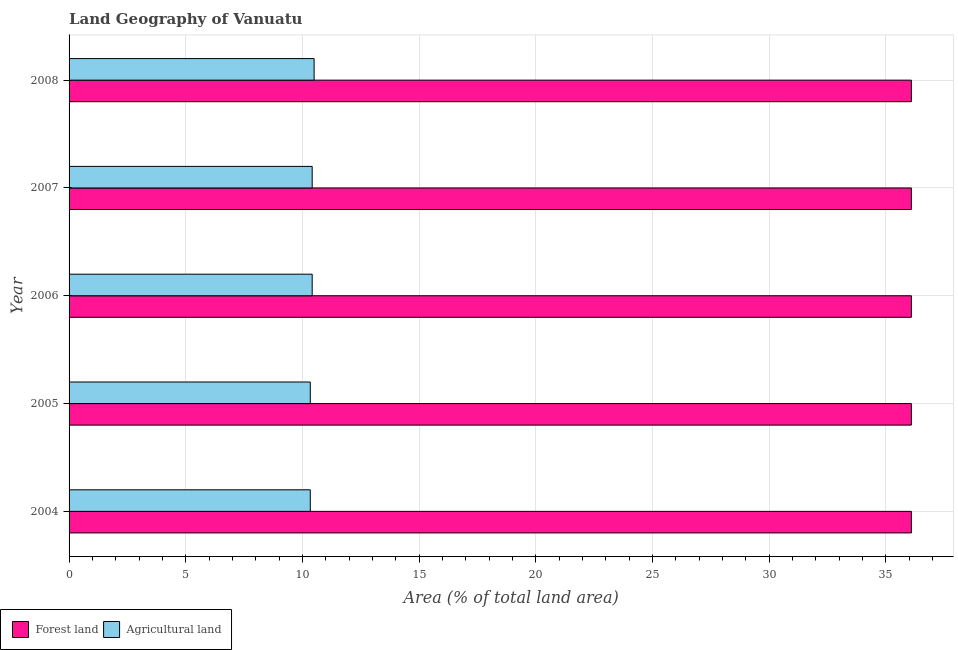How many different coloured bars are there?
Make the answer very short. 2. Are the number of bars per tick equal to the number of legend labels?
Your response must be concise. Yes. Are the number of bars on each tick of the Y-axis equal?
Give a very brief answer. Yes. How many bars are there on the 4th tick from the top?
Keep it short and to the point. 2. How many bars are there on the 2nd tick from the bottom?
Offer a terse response. 2. What is the label of the 5th group of bars from the top?
Ensure brevity in your answer.  2004. What is the percentage of land area under forests in 2005?
Keep it short and to the point. 36.1. Across all years, what is the maximum percentage of land area under agriculture?
Your answer should be very brief. 10.5. Across all years, what is the minimum percentage of land area under agriculture?
Your response must be concise. 10.34. In which year was the percentage of land area under agriculture maximum?
Offer a very short reply. 2008. In which year was the percentage of land area under forests minimum?
Your answer should be compact. 2004. What is the total percentage of land area under agriculture in the graph?
Offer a terse response. 52.01. What is the difference between the percentage of land area under agriculture in 2004 and that in 2006?
Provide a short and direct response. -0.08. What is the difference between the percentage of land area under forests in 2005 and the percentage of land area under agriculture in 2008?
Your answer should be very brief. 25.59. What is the average percentage of land area under forests per year?
Your response must be concise. 36.09. In the year 2004, what is the difference between the percentage of land area under forests and percentage of land area under agriculture?
Your answer should be very brief. 25.76. Is the percentage of land area under forests in 2004 less than that in 2005?
Keep it short and to the point. No. What is the difference between the highest and the lowest percentage of land area under agriculture?
Offer a terse response. 0.16. In how many years, is the percentage of land area under agriculture greater than the average percentage of land area under agriculture taken over all years?
Your response must be concise. 3. What does the 1st bar from the top in 2005 represents?
Your response must be concise. Agricultural land. What does the 2nd bar from the bottom in 2007 represents?
Your answer should be compact. Agricultural land. How many bars are there?
Ensure brevity in your answer.  10. Are all the bars in the graph horizontal?
Your answer should be compact. Yes. Are the values on the major ticks of X-axis written in scientific E-notation?
Offer a very short reply. No. Where does the legend appear in the graph?
Offer a very short reply. Bottom left. What is the title of the graph?
Make the answer very short. Land Geography of Vanuatu. Does "Private creditors" appear as one of the legend labels in the graph?
Provide a short and direct response. No. What is the label or title of the X-axis?
Make the answer very short. Area (% of total land area). What is the label or title of the Y-axis?
Your answer should be compact. Year. What is the Area (% of total land area) of Forest land in 2004?
Your answer should be very brief. 36.1. What is the Area (% of total land area) of Agricultural land in 2004?
Your answer should be very brief. 10.34. What is the Area (% of total land area) in Forest land in 2005?
Offer a terse response. 36.1. What is the Area (% of total land area) of Agricultural land in 2005?
Offer a very short reply. 10.34. What is the Area (% of total land area) of Forest land in 2006?
Keep it short and to the point. 36.1. What is the Area (% of total land area) in Agricultural land in 2006?
Make the answer very short. 10.42. What is the Area (% of total land area) in Forest land in 2007?
Ensure brevity in your answer.  36.1. What is the Area (% of total land area) of Agricultural land in 2007?
Keep it short and to the point. 10.42. What is the Area (% of total land area) in Forest land in 2008?
Your answer should be very brief. 36.1. What is the Area (% of total land area) of Agricultural land in 2008?
Provide a short and direct response. 10.5. Across all years, what is the maximum Area (% of total land area) of Forest land?
Provide a short and direct response. 36.1. Across all years, what is the maximum Area (% of total land area) of Agricultural land?
Your response must be concise. 10.5. Across all years, what is the minimum Area (% of total land area) in Forest land?
Give a very brief answer. 36.1. Across all years, what is the minimum Area (% of total land area) in Agricultural land?
Your answer should be compact. 10.34. What is the total Area (% of total land area) of Forest land in the graph?
Your answer should be compact. 180.48. What is the total Area (% of total land area) of Agricultural land in the graph?
Your answer should be very brief. 52.01. What is the difference between the Area (% of total land area) in Forest land in 2004 and that in 2005?
Offer a very short reply. 0. What is the difference between the Area (% of total land area) in Forest land in 2004 and that in 2006?
Keep it short and to the point. 0. What is the difference between the Area (% of total land area) in Agricultural land in 2004 and that in 2006?
Provide a succinct answer. -0.08. What is the difference between the Area (% of total land area) in Forest land in 2004 and that in 2007?
Offer a very short reply. 0. What is the difference between the Area (% of total land area) of Agricultural land in 2004 and that in 2007?
Offer a terse response. -0.08. What is the difference between the Area (% of total land area) in Agricultural land in 2004 and that in 2008?
Provide a succinct answer. -0.16. What is the difference between the Area (% of total land area) in Forest land in 2005 and that in 2006?
Your answer should be compact. 0. What is the difference between the Area (% of total land area) in Agricultural land in 2005 and that in 2006?
Your answer should be very brief. -0.08. What is the difference between the Area (% of total land area) of Forest land in 2005 and that in 2007?
Keep it short and to the point. 0. What is the difference between the Area (% of total land area) in Agricultural land in 2005 and that in 2007?
Make the answer very short. -0.08. What is the difference between the Area (% of total land area) in Forest land in 2005 and that in 2008?
Make the answer very short. 0. What is the difference between the Area (% of total land area) of Agricultural land in 2005 and that in 2008?
Give a very brief answer. -0.16. What is the difference between the Area (% of total land area) in Agricultural land in 2006 and that in 2007?
Offer a very short reply. 0. What is the difference between the Area (% of total land area) in Forest land in 2006 and that in 2008?
Provide a short and direct response. 0. What is the difference between the Area (% of total land area) of Agricultural land in 2006 and that in 2008?
Your response must be concise. -0.08. What is the difference between the Area (% of total land area) in Forest land in 2007 and that in 2008?
Provide a succinct answer. 0. What is the difference between the Area (% of total land area) of Agricultural land in 2007 and that in 2008?
Your answer should be very brief. -0.08. What is the difference between the Area (% of total land area) in Forest land in 2004 and the Area (% of total land area) in Agricultural land in 2005?
Make the answer very short. 25.76. What is the difference between the Area (% of total land area) in Forest land in 2004 and the Area (% of total land area) in Agricultural land in 2006?
Keep it short and to the point. 25.68. What is the difference between the Area (% of total land area) of Forest land in 2004 and the Area (% of total land area) of Agricultural land in 2007?
Offer a very short reply. 25.68. What is the difference between the Area (% of total land area) of Forest land in 2004 and the Area (% of total land area) of Agricultural land in 2008?
Provide a short and direct response. 25.59. What is the difference between the Area (% of total land area) of Forest land in 2005 and the Area (% of total land area) of Agricultural land in 2006?
Offer a terse response. 25.68. What is the difference between the Area (% of total land area) in Forest land in 2005 and the Area (% of total land area) in Agricultural land in 2007?
Your answer should be compact. 25.68. What is the difference between the Area (% of total land area) in Forest land in 2005 and the Area (% of total land area) in Agricultural land in 2008?
Ensure brevity in your answer.  25.59. What is the difference between the Area (% of total land area) of Forest land in 2006 and the Area (% of total land area) of Agricultural land in 2007?
Make the answer very short. 25.68. What is the difference between the Area (% of total land area) of Forest land in 2006 and the Area (% of total land area) of Agricultural land in 2008?
Your response must be concise. 25.59. What is the difference between the Area (% of total land area) in Forest land in 2007 and the Area (% of total land area) in Agricultural land in 2008?
Your response must be concise. 25.59. What is the average Area (% of total land area) in Forest land per year?
Your response must be concise. 36.1. What is the average Area (% of total land area) in Agricultural land per year?
Make the answer very short. 10.4. In the year 2004, what is the difference between the Area (% of total land area) of Forest land and Area (% of total land area) of Agricultural land?
Your answer should be compact. 25.76. In the year 2005, what is the difference between the Area (% of total land area) of Forest land and Area (% of total land area) of Agricultural land?
Your response must be concise. 25.76. In the year 2006, what is the difference between the Area (% of total land area) in Forest land and Area (% of total land area) in Agricultural land?
Keep it short and to the point. 25.68. In the year 2007, what is the difference between the Area (% of total land area) of Forest land and Area (% of total land area) of Agricultural land?
Provide a succinct answer. 25.68. In the year 2008, what is the difference between the Area (% of total land area) of Forest land and Area (% of total land area) of Agricultural land?
Your answer should be compact. 25.59. What is the ratio of the Area (% of total land area) of Forest land in 2004 to that in 2005?
Provide a succinct answer. 1. What is the ratio of the Area (% of total land area) in Agricultural land in 2004 to that in 2005?
Ensure brevity in your answer.  1. What is the ratio of the Area (% of total land area) in Forest land in 2004 to that in 2006?
Keep it short and to the point. 1. What is the ratio of the Area (% of total land area) in Agricultural land in 2004 to that in 2007?
Your answer should be compact. 0.99. What is the ratio of the Area (% of total land area) of Forest land in 2004 to that in 2008?
Provide a succinct answer. 1. What is the ratio of the Area (% of total land area) of Agricultural land in 2004 to that in 2008?
Your answer should be compact. 0.98. What is the ratio of the Area (% of total land area) in Forest land in 2005 to that in 2006?
Offer a terse response. 1. What is the ratio of the Area (% of total land area) in Agricultural land in 2005 to that in 2006?
Ensure brevity in your answer.  0.99. What is the ratio of the Area (% of total land area) of Agricultural land in 2005 to that in 2007?
Offer a very short reply. 0.99. What is the ratio of the Area (% of total land area) in Agricultural land in 2005 to that in 2008?
Provide a succinct answer. 0.98. What is the ratio of the Area (% of total land area) of Agricultural land in 2006 to that in 2008?
Give a very brief answer. 0.99. What is the ratio of the Area (% of total land area) in Forest land in 2007 to that in 2008?
Your answer should be very brief. 1. What is the difference between the highest and the second highest Area (% of total land area) of Forest land?
Keep it short and to the point. 0. What is the difference between the highest and the second highest Area (% of total land area) of Agricultural land?
Your response must be concise. 0.08. What is the difference between the highest and the lowest Area (% of total land area) of Agricultural land?
Ensure brevity in your answer.  0.16. 